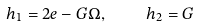<formula> <loc_0><loc_0><loc_500><loc_500>h _ { 1 } = 2 e - G \Omega , \quad \ h _ { 2 } = G</formula> 